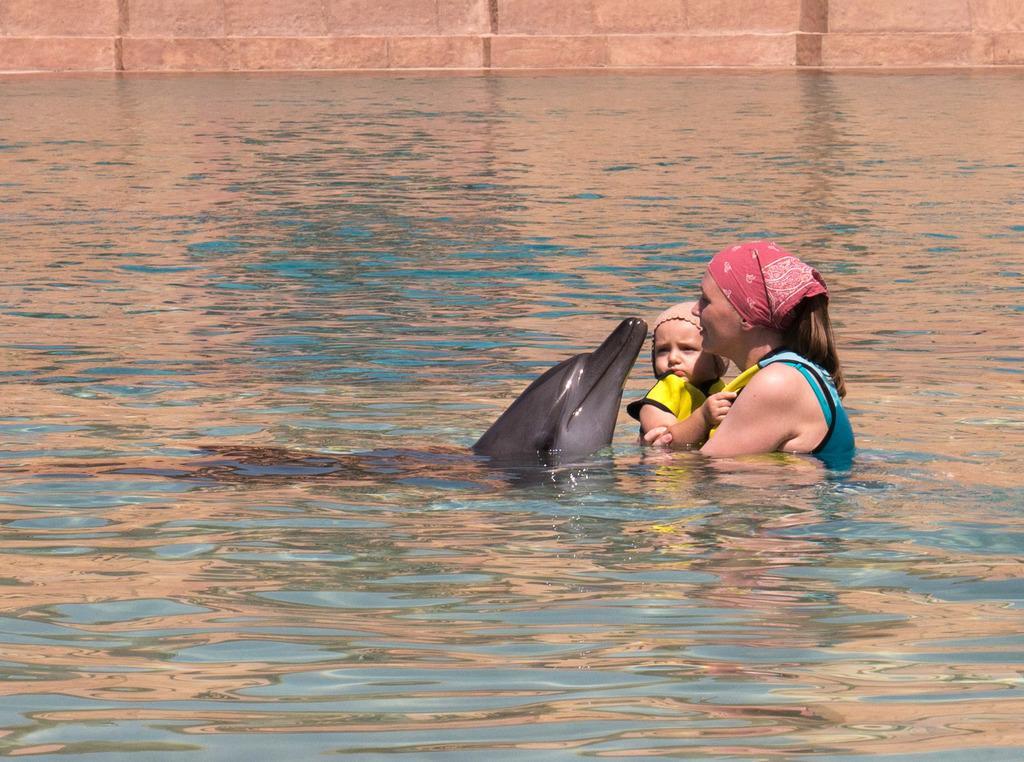Could you give a brief overview of what you see in this image? This picture shows dolphin in the water and we see a woman holding a baby in her hand and she wore a cloth on her head and a cap on the baby's head and we see a wall. 